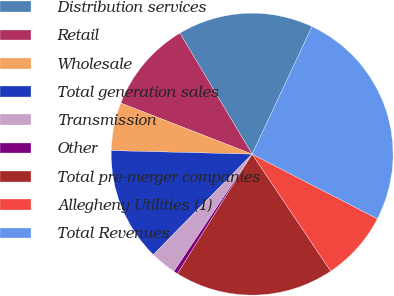<chart> <loc_0><loc_0><loc_500><loc_500><pie_chart><fcel>Distribution services<fcel>Retail<fcel>Wholesale<fcel>Total generation sales<fcel>Transmission<fcel>Other<fcel>Total pre-merger companies<fcel>Allegheny Utilities (1)<fcel>Total Revenues<nl><fcel>15.55%<fcel>10.53%<fcel>5.5%<fcel>13.04%<fcel>2.99%<fcel>0.48%<fcel>18.3%<fcel>8.01%<fcel>25.59%<nl></chart> 